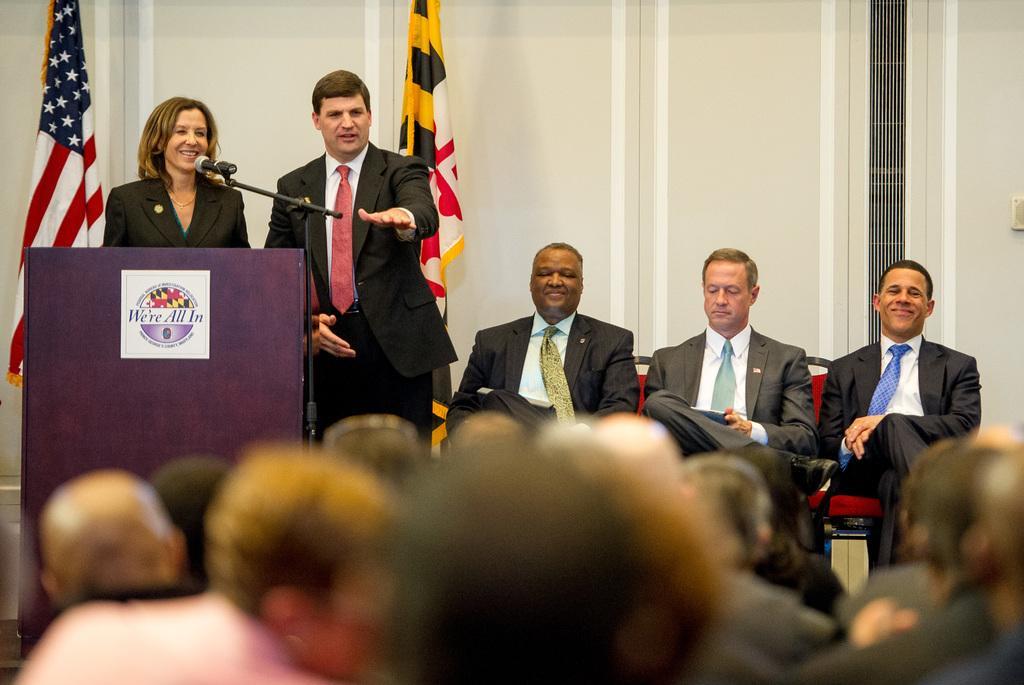Could you give a brief overview of what you see in this image? In this image, we can see a group of people. Few are sitting on the chairs and smiling. Left side of the image, we can see a woman is there behind the podium. Here we can see sticker, microphone with stand. Background we can see two flags, wall. At the bottom of the image, we can see a blur view. 